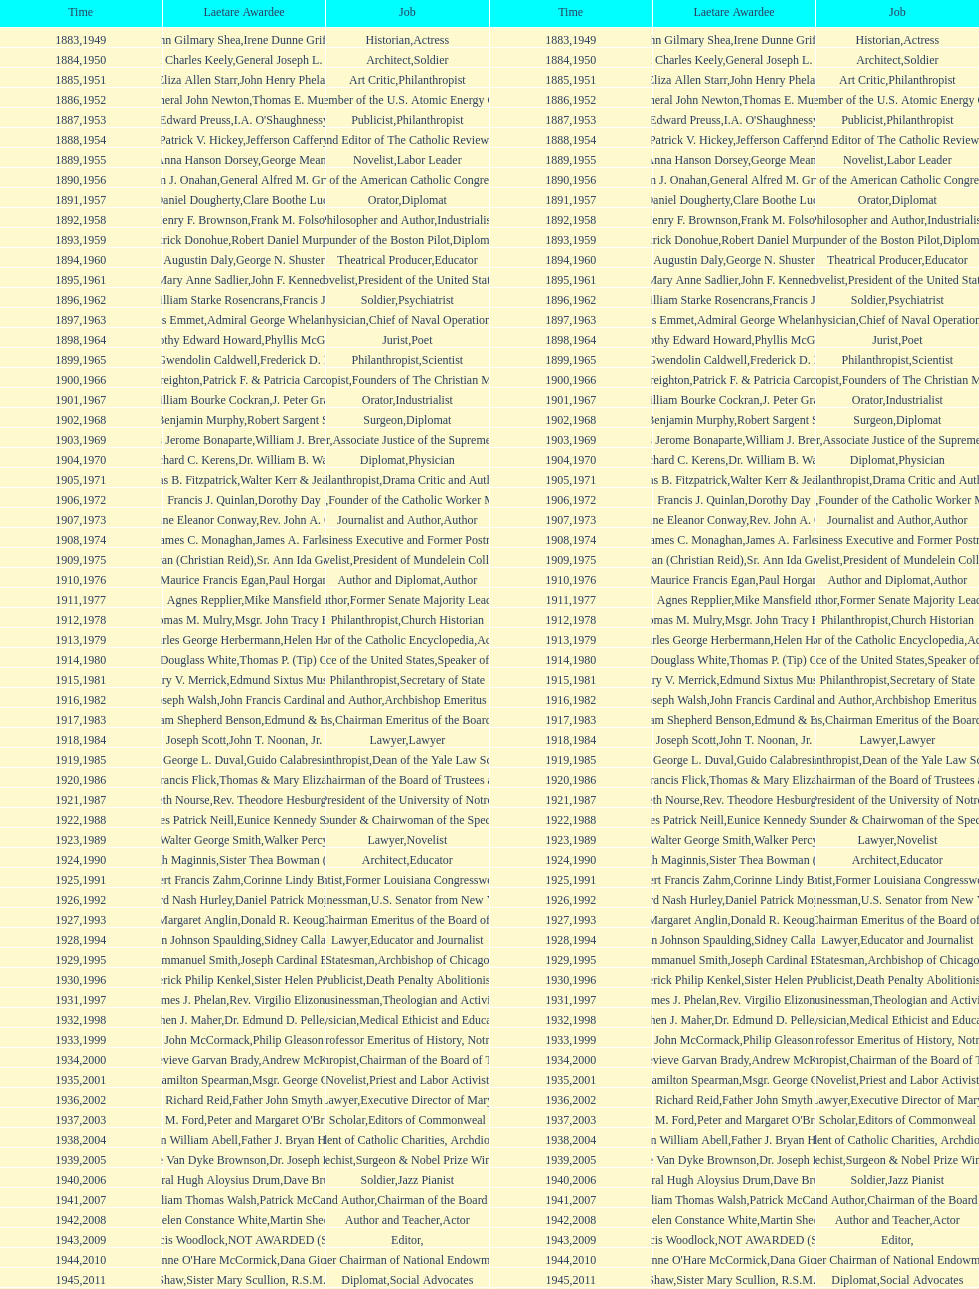Who won the medal after thomas e. murray in 1952? I.A. O'Shaughnessy. Could you help me parse every detail presented in this table? {'header': ['Time', 'Laetare Awardee', 'Job', 'Time', 'Laetare Awardee', 'Job'], 'rows': [['1883', 'John Gilmary Shea', 'Historian', '1949', 'Irene Dunne Griffin', 'Actress'], ['1884', 'Patrick Charles Keely', 'Architect', '1950', 'General Joseph L. Collins', 'Soldier'], ['1885', 'Eliza Allen Starr', 'Art Critic', '1951', 'John Henry Phelan', 'Philanthropist'], ['1886', 'General John Newton', 'Engineer', '1952', 'Thomas E. Murray', 'Member of the U.S. Atomic Energy Commission'], ['1887', 'Edward Preuss', 'Publicist', '1953', "I.A. O'Shaughnessy", 'Philanthropist'], ['1888', 'Patrick V. Hickey', 'Founder and Editor of The Catholic Review', '1954', 'Jefferson Caffery', 'Diplomat'], ['1889', 'Anna Hanson Dorsey', 'Novelist', '1955', 'George Meany', 'Labor Leader'], ['1890', 'William J. Onahan', 'Organizer of the American Catholic Congress', '1956', 'General Alfred M. Gruenther', 'Soldier'], ['1891', 'Daniel Dougherty', 'Orator', '1957', 'Clare Boothe Luce', 'Diplomat'], ['1892', 'Henry F. Brownson', 'Philosopher and Author', '1958', 'Frank M. Folsom', 'Industrialist'], ['1893', 'Patrick Donohue', 'Founder of the Boston Pilot', '1959', 'Robert Daniel Murphy', 'Diplomat'], ['1894', 'Augustin Daly', 'Theatrical Producer', '1960', 'George N. Shuster', 'Educator'], ['1895', 'Mary Anne Sadlier', 'Novelist', '1961', 'John F. Kennedy', 'President of the United States'], ['1896', 'General William Starke Rosencrans', 'Soldier', '1962', 'Francis J. Braceland', 'Psychiatrist'], ['1897', 'Thomas Addis Emmet', 'Physician', '1963', 'Admiral George Whelan Anderson, Jr.', 'Chief of Naval Operations'], ['1898', 'Timothy Edward Howard', 'Jurist', '1964', 'Phyllis McGinley', 'Poet'], ['1899', 'Mary Gwendolin Caldwell', 'Philanthropist', '1965', 'Frederick D. Rossini', 'Scientist'], ['1900', 'John A. Creighton', 'Philanthropist', '1966', 'Patrick F. & Patricia Caron Crowley', 'Founders of The Christian Movement'], ['1901', 'William Bourke Cockran', 'Orator', '1967', 'J. Peter Grace', 'Industrialist'], ['1902', 'John Benjamin Murphy', 'Surgeon', '1968', 'Robert Sargent Shriver', 'Diplomat'], ['1903', 'Charles Jerome Bonaparte', 'Lawyer', '1969', 'William J. Brennan Jr.', 'Associate Justice of the Supreme Court'], ['1904', 'Richard C. Kerens', 'Diplomat', '1970', 'Dr. William B. Walsh', 'Physician'], ['1905', 'Thomas B. Fitzpatrick', 'Philanthropist', '1971', 'Walter Kerr & Jean Kerr', 'Drama Critic and Author'], ['1906', 'Francis J. Quinlan', 'Physician', '1972', 'Dorothy Day', 'Founder of the Catholic Worker Movement'], ['1907', 'Katherine Eleanor Conway', 'Journalist and Author', '1973', "Rev. John A. O'Brien", 'Author'], ['1908', 'James C. Monaghan', 'Economist', '1974', 'James A. Farley', 'Business Executive and Former Postmaster General'], ['1909', 'Frances Tieran (Christian Reid)', 'Novelist', '1975', 'Sr. Ann Ida Gannon, BMV', 'President of Mundelein College'], ['1910', 'Maurice Francis Egan', 'Author and Diplomat', '1976', 'Paul Horgan', 'Author'], ['1911', 'Agnes Repplier', 'Author', '1977', 'Mike Mansfield', 'Former Senate Majority Leader'], ['1912', 'Thomas M. Mulry', 'Philanthropist', '1978', 'Msgr. John Tracy Ellis', 'Church Historian'], ['1913', 'Charles George Herbermann', 'Editor of the Catholic Encyclopedia', '1979', 'Helen Hayes', 'Actress'], ['1914', 'Edward Douglass White', 'Chief Justice of the United States', '1980', "Thomas P. (Tip) O'Neill Jr.", 'Speaker of the House'], ['1915', 'Mary V. Merrick', 'Philanthropist', '1981', 'Edmund Sixtus Muskie', 'Secretary of State'], ['1916', 'James Joseph Walsh', 'Physician and Author', '1982', 'John Francis Cardinal Dearden', 'Archbishop Emeritus of Detroit'], ['1917', 'Admiral William Shepherd Benson', 'Chief of Naval Operations', '1983', 'Edmund & Evelyn Stephan', 'Chairman Emeritus of the Board of Trustees and his wife'], ['1918', 'Joseph Scott', 'Lawyer', '1984', 'John T. Noonan, Jr.', 'Lawyer'], ['1919', 'George L. Duval', 'Philanthropist', '1985', 'Guido Calabresi', 'Dean of the Yale Law School'], ['1920', 'Lawrence Francis Flick', 'Physician', '1986', 'Thomas & Mary Elizabeth Carney', 'Chairman of the Board of Trustees and his wife'], ['1921', 'Elizabeth Nourse', 'Artist', '1987', 'Rev. Theodore Hesburgh, CSC', 'President of the University of Notre Dame'], ['1922', 'Charles Patrick Neill', 'Economist', '1988', 'Eunice Kennedy Shriver', 'Founder & Chairwoman of the Special Olympics'], ['1923', 'Walter George Smith', 'Lawyer', '1989', 'Walker Percy', 'Novelist'], ['1924', 'Charles Donagh Maginnis', 'Architect', '1990', 'Sister Thea Bowman (posthumously)', 'Educator'], ['1925', 'Albert Francis Zahm', 'Scientist', '1991', 'Corinne Lindy Boggs', 'Former Louisiana Congresswoman'], ['1926', 'Edward Nash Hurley', 'Businessman', '1992', 'Daniel Patrick Moynihan', 'U.S. Senator from New York'], ['1927', 'Margaret Anglin', 'Actress', '1993', 'Donald R. Keough', 'Chairman Emeritus of the Board of Trustees'], ['1928', 'John Johnson Spaulding', 'Lawyer', '1994', 'Sidney Callahan', 'Educator and Journalist'], ['1929', 'Alfred Emmanuel Smith', 'Statesman', '1995', 'Joseph Cardinal Bernardin', 'Archbishop of Chicago'], ['1930', 'Frederick Philip Kenkel', 'Publicist', '1996', 'Sister Helen Prejean', 'Death Penalty Abolitionist'], ['1931', 'James J. Phelan', 'Businessman', '1997', 'Rev. Virgilio Elizondo', 'Theologian and Activist'], ['1932', 'Stephen J. Maher', 'Physician', '1998', 'Dr. Edmund D. Pellegrino', 'Medical Ethicist and Educator'], ['1933', 'John McCormack', 'Artist', '1999', 'Philip Gleason', 'Professor Emeritus of History, Notre Dame'], ['1934', 'Genevieve Garvan Brady', 'Philanthropist', '2000', 'Andrew McKenna', 'Chairman of the Board of Trustees'], ['1935', 'Francis Hamilton Spearman', 'Novelist', '2001', 'Msgr. George G. Higgins', 'Priest and Labor Activist'], ['1936', 'Richard Reid', 'Journalist and Lawyer', '2002', 'Father John Smyth', 'Executive Director of Maryville Academy'], ['1937', 'Jeremiah D. M. Ford', 'Scholar', '2003', "Peter and Margaret O'Brien Steinfels", 'Editors of Commonweal'], ['1938', 'Irvin William Abell', 'Surgeon', '2004', 'Father J. Bryan Hehir', 'President of Catholic Charities, Archdiocese of Boston'], ['1939', 'Josephine Van Dyke Brownson', 'Catechist', '2005', 'Dr. Joseph E. Murray', 'Surgeon & Nobel Prize Winner'], ['1940', 'General Hugh Aloysius Drum', 'Soldier', '2006', 'Dave Brubeck', 'Jazz Pianist'], ['1941', 'William Thomas Walsh', 'Journalist and Author', '2007', 'Patrick McCartan', 'Chairman of the Board of Trustees'], ['1942', 'Helen Constance White', 'Author and Teacher', '2008', 'Martin Sheen', 'Actor'], ['1943', 'Thomas Francis Woodlock', 'Editor', '2009', 'NOT AWARDED (SEE BELOW)', ''], ['1944', "Anne O'Hare McCormick", 'Journalist', '2010', 'Dana Gioia', 'Former Chairman of National Endowment for the Arts'], ['1945', 'Gardiner Howland Shaw', 'Diplomat', '2011', 'Sister Mary Scullion, R.S.M., & Joan McConnon', 'Social Advocates'], ['1946', 'Carlton J. H. Hayes', 'Historian and Diplomat', '2012', 'Ken Hackett', 'Former President of Catholic Relief Services'], ['1947', 'William G. Bruce', 'Publisher and Civic Leader', '2013', 'Sister Susanne Gallagher, S.P.\\nSister Mary Therese Harrington, S.H.\\nRev. James H. McCarthy', 'Founders of S.P.R.E.D. (Special Religious Education Development Network)'], ['1948', 'Frank C. Walker', 'Postmaster General and Civic Leader', '2014', 'Kenneth R. Miller', 'Professor of Biology at Brown University']]} 